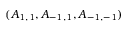<formula> <loc_0><loc_0><loc_500><loc_500>( A _ { 1 , 1 } , A _ { - 1 , 1 } , A _ { - 1 , - 1 } )</formula> 